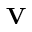<formula> <loc_0><loc_0><loc_500><loc_500>{ \mathbf V }</formula> 